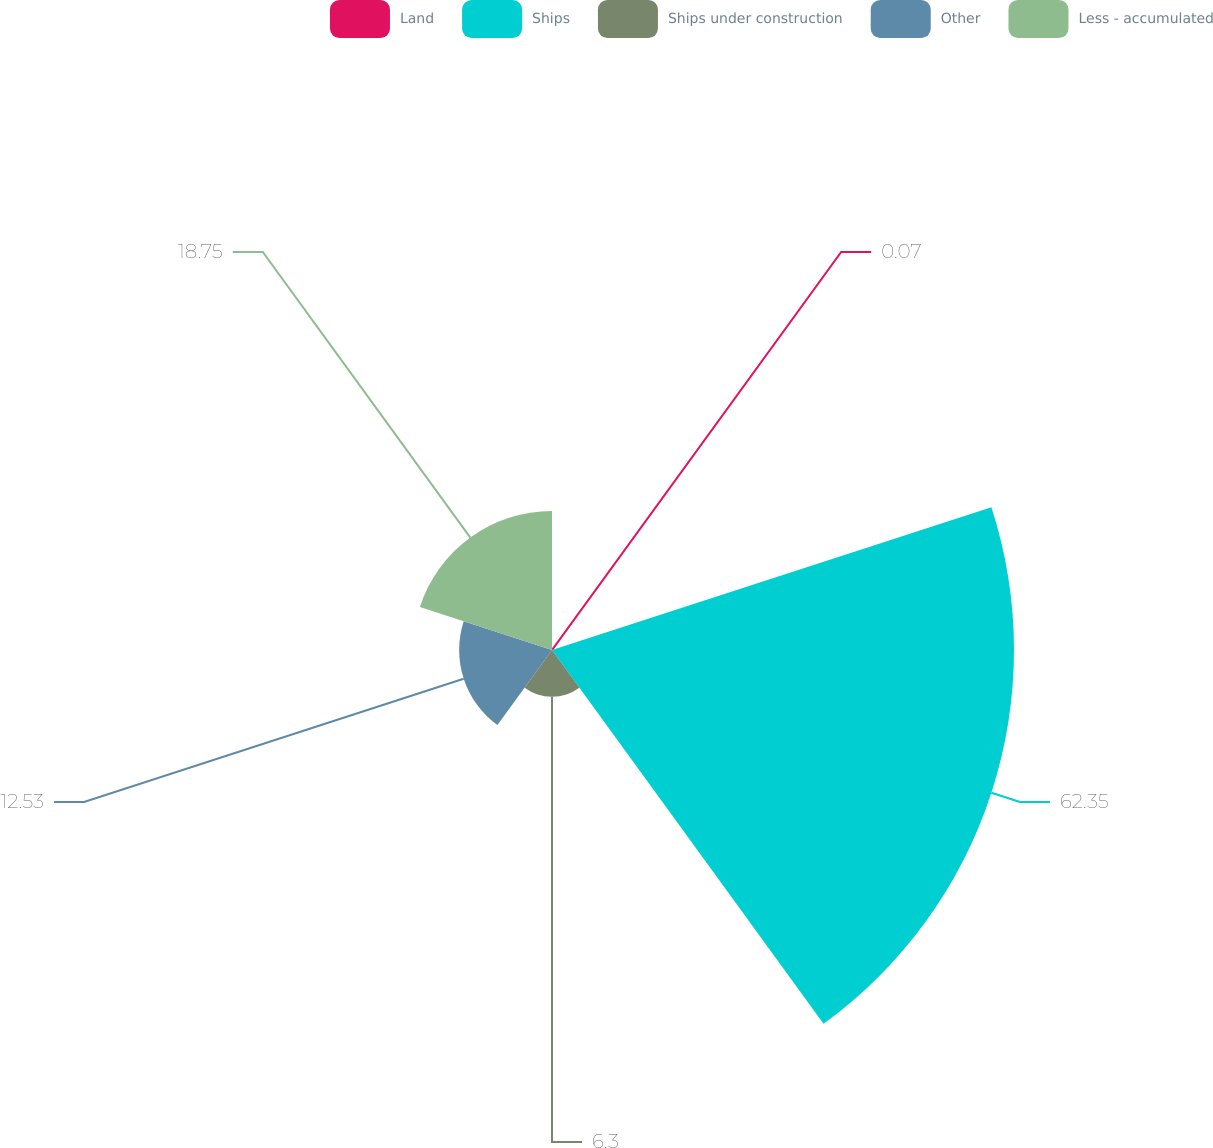<chart> <loc_0><loc_0><loc_500><loc_500><pie_chart><fcel>Land<fcel>Ships<fcel>Ships under construction<fcel>Other<fcel>Less - accumulated<nl><fcel>0.07%<fcel>62.35%<fcel>6.3%<fcel>12.53%<fcel>18.75%<nl></chart> 